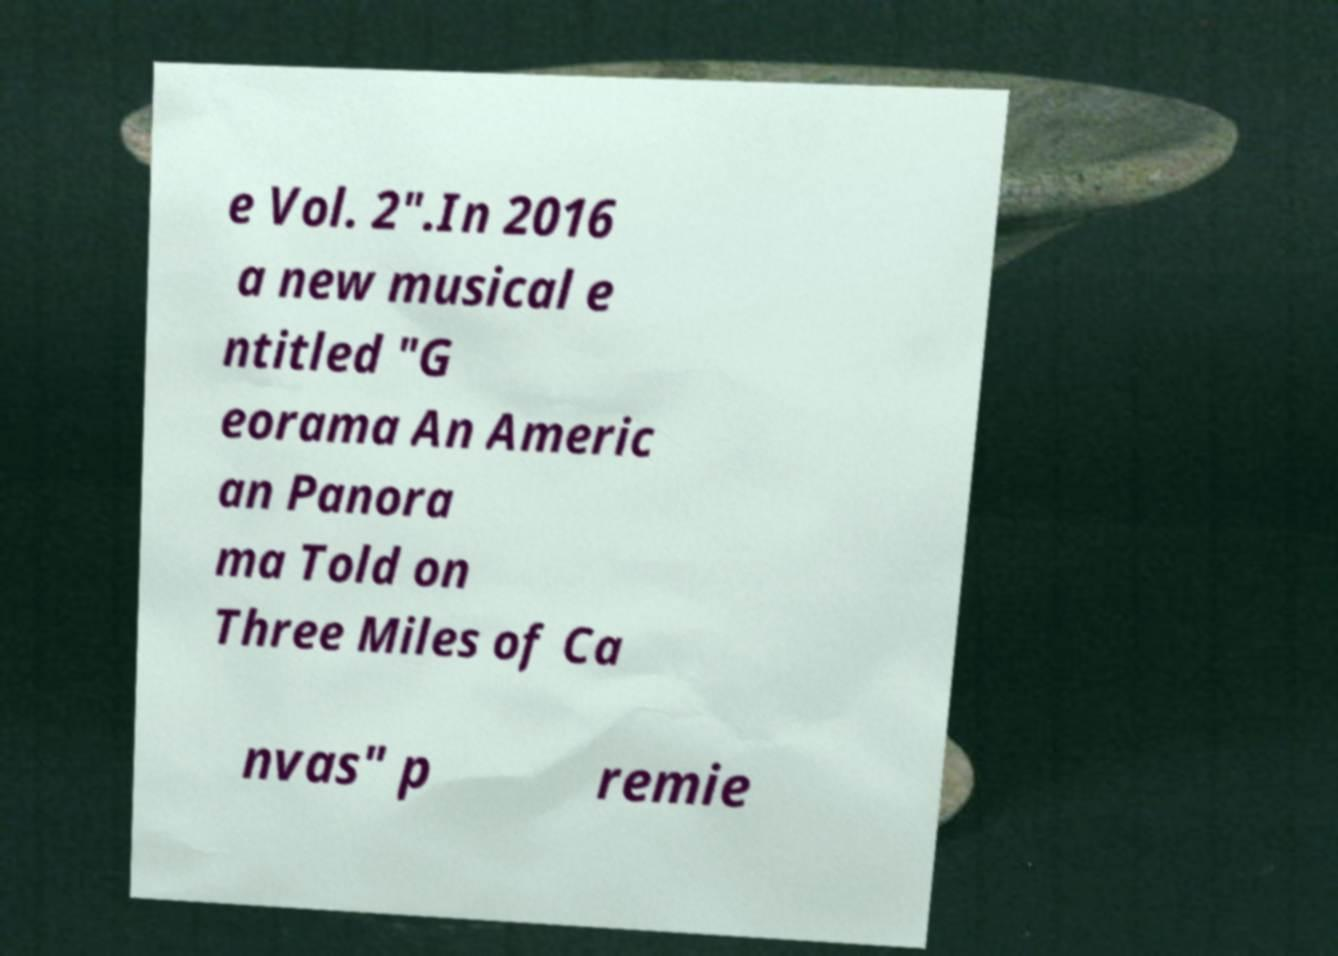For documentation purposes, I need the text within this image transcribed. Could you provide that? e Vol. 2".In 2016 a new musical e ntitled "G eorama An Americ an Panora ma Told on Three Miles of Ca nvas" p remie 